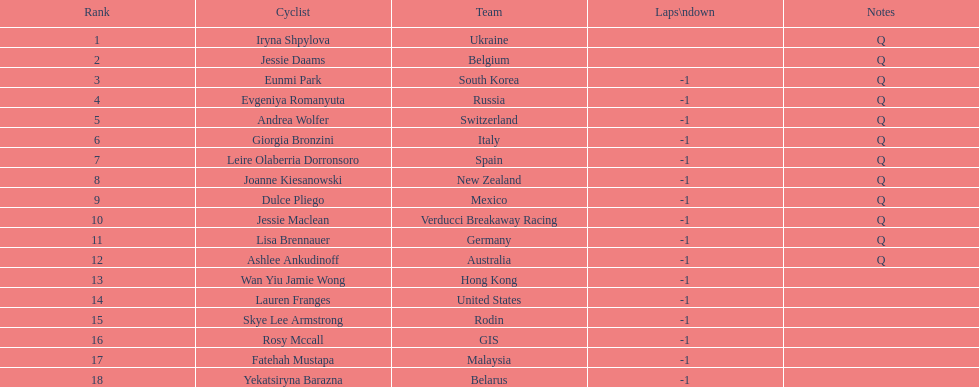Who was the first competitor to finish the race a lap behind? Eunmi Park. 